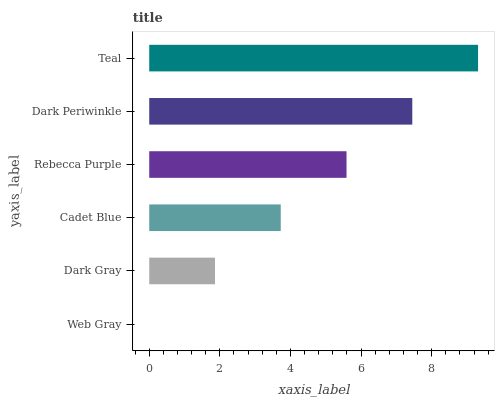Is Web Gray the minimum?
Answer yes or no. Yes. Is Teal the maximum?
Answer yes or no. Yes. Is Dark Gray the minimum?
Answer yes or no. No. Is Dark Gray the maximum?
Answer yes or no. No. Is Dark Gray greater than Web Gray?
Answer yes or no. Yes. Is Web Gray less than Dark Gray?
Answer yes or no. Yes. Is Web Gray greater than Dark Gray?
Answer yes or no. No. Is Dark Gray less than Web Gray?
Answer yes or no. No. Is Rebecca Purple the high median?
Answer yes or no. Yes. Is Cadet Blue the low median?
Answer yes or no. Yes. Is Teal the high median?
Answer yes or no. No. Is Teal the low median?
Answer yes or no. No. 